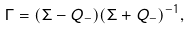Convert formula to latex. <formula><loc_0><loc_0><loc_500><loc_500>\Gamma = ( \Sigma - Q _ { - } ) ( \Sigma + Q _ { - } ) ^ { - 1 } ,</formula> 